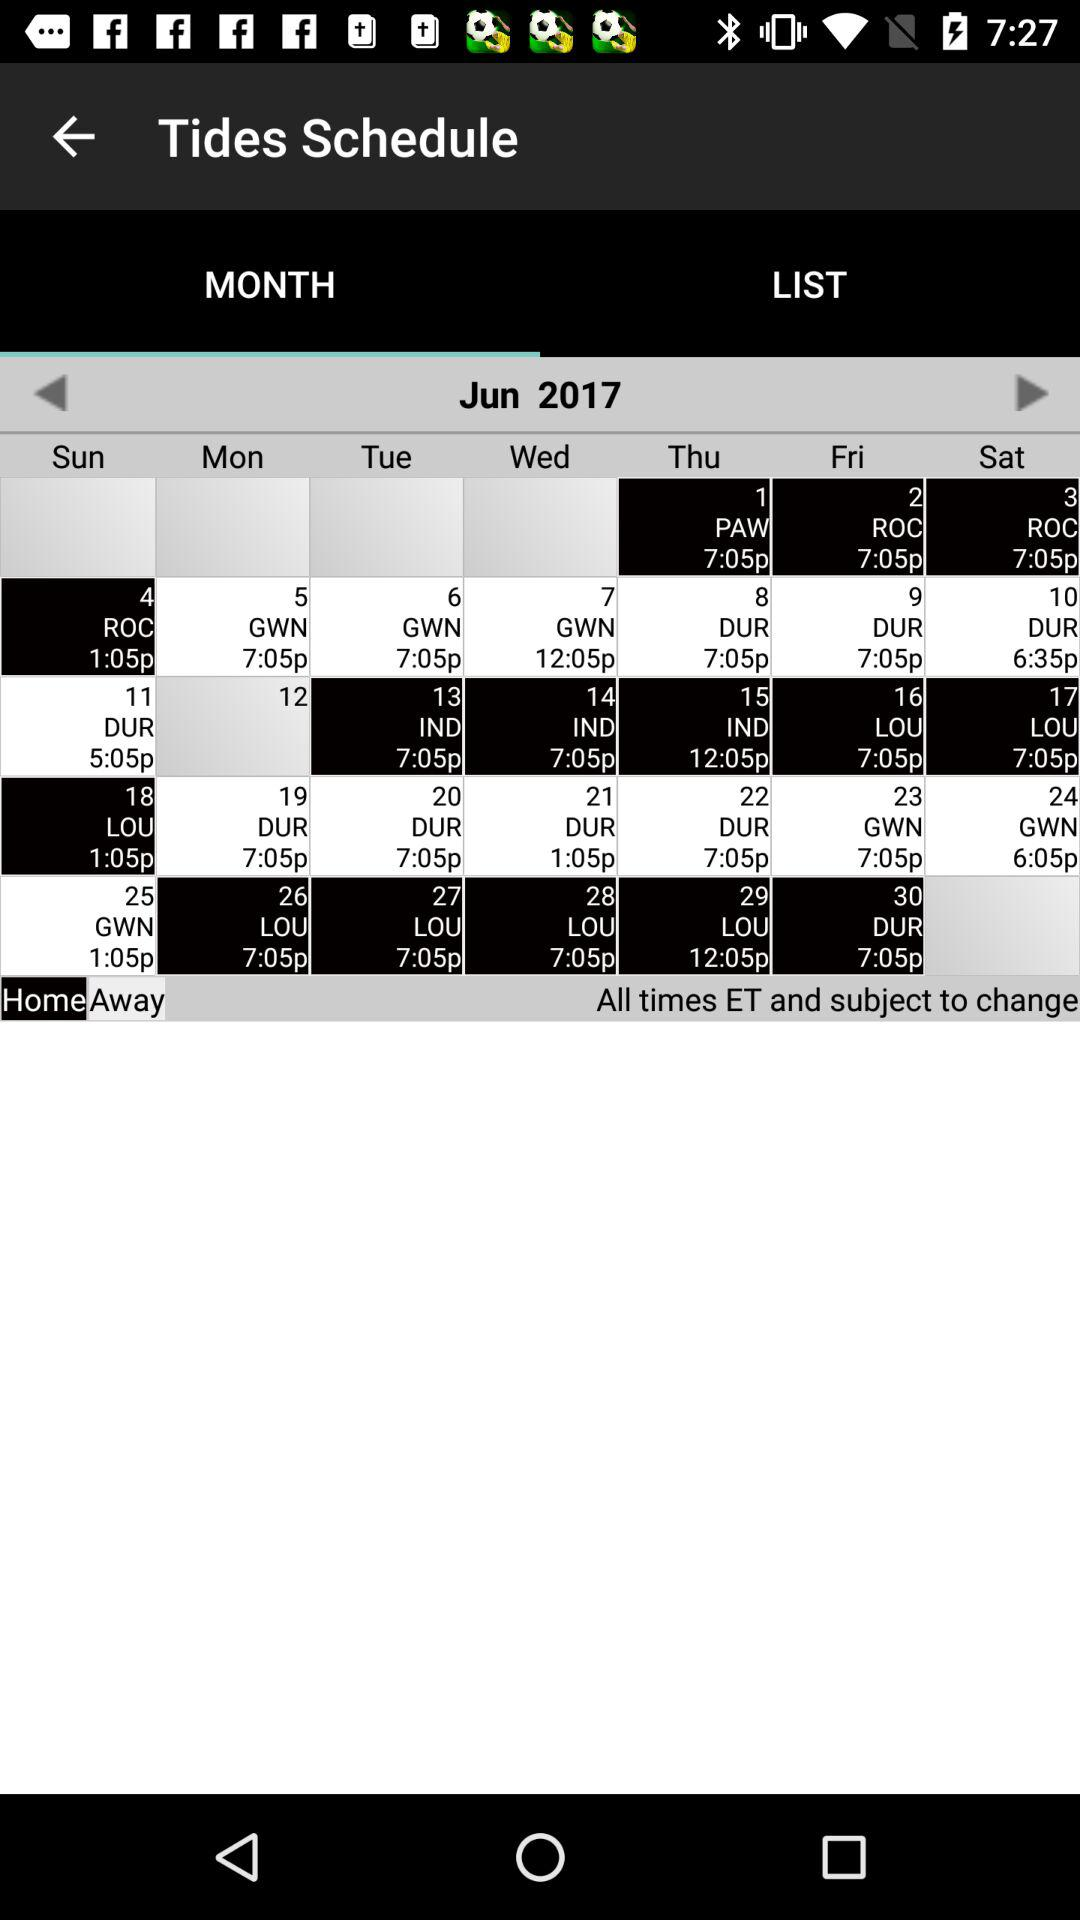Which month is displayed on the calendar? The displayed month is June. 